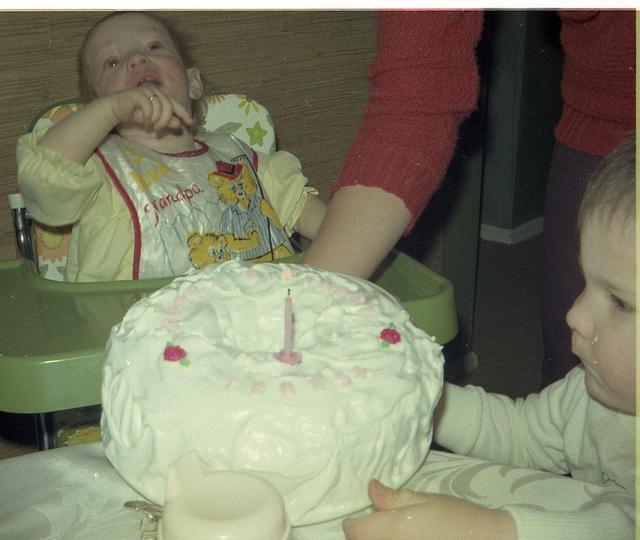Why is there a candle in the cake?
Make your selection and explain in format: 'Answer: answer
Rationale: rationale.'
Options: To celebrate, for light, to eat, to cook. Answer: to celebrate.
Rationale: Candles are put on cakes to celebrate birthdays. 